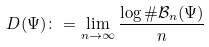Convert formula to latex. <formula><loc_0><loc_0><loc_500><loc_500>D ( \Psi ) \colon = \lim _ { n \to \infty } \frac { \log \# { \mathcal { B } } _ { n } ( \Psi ) } { n }</formula> 